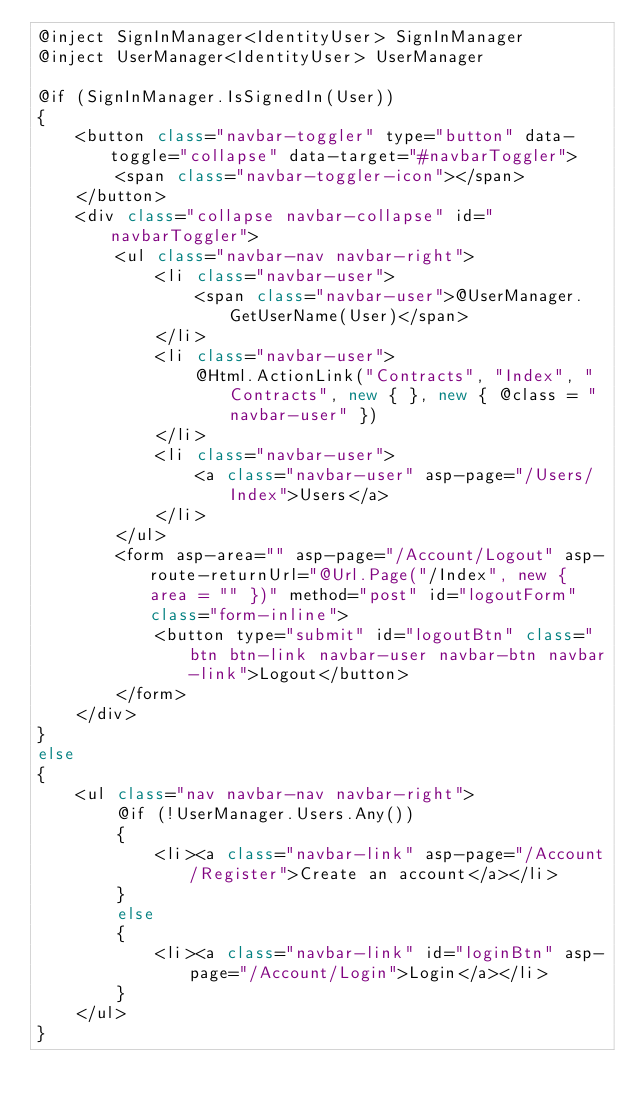Convert code to text. <code><loc_0><loc_0><loc_500><loc_500><_C#_>@inject SignInManager<IdentityUser> SignInManager
@inject UserManager<IdentityUser> UserManager

@if (SignInManager.IsSignedIn(User))
{
    <button class="navbar-toggler" type="button" data-toggle="collapse" data-target="#navbarToggler">
        <span class="navbar-toggler-icon"></span>
    </button>
    <div class="collapse navbar-collapse" id="navbarToggler">
        <ul class="navbar-nav navbar-right">
            <li class="navbar-user">
                <span class="navbar-user">@UserManager.GetUserName(User)</span>
            </li>
            <li class="navbar-user">
                @Html.ActionLink("Contracts", "Index", "Contracts", new { }, new { @class = "navbar-user" })
            </li>
            <li class="navbar-user">
                <a class="navbar-user" asp-page="/Users/Index">Users</a>
            </li>
        </ul>
        <form asp-area="" asp-page="/Account/Logout" asp-route-returnUrl="@Url.Page("/Index", new { area = "" })" method="post" id="logoutForm" class="form-inline">
            <button type="submit" id="logoutBtn" class="btn btn-link navbar-user navbar-btn navbar-link">Logout</button>
        </form>
    </div>
}
else
{
    <ul class="nav navbar-nav navbar-right">
        @if (!UserManager.Users.Any())
        {
            <li><a class="navbar-link" asp-page="/Account/Register">Create an account</a></li>
        }
        else
        {
            <li><a class="navbar-link" id="loginBtn" asp-page="/Account/Login">Login</a></li>
        }
    </ul>
}
</code> 